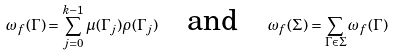<formula> <loc_0><loc_0><loc_500><loc_500>\omega _ { f } ( \Gamma ) = \sum _ { j = 0 } ^ { k - 1 } \mu ( \Gamma _ { j } ) \rho ( \Gamma _ { j } ) \quad \text {and} \quad \omega _ { f } ( \Sigma ) = \sum _ { \Gamma \in \Sigma } \omega _ { f } ( \Gamma )</formula> 